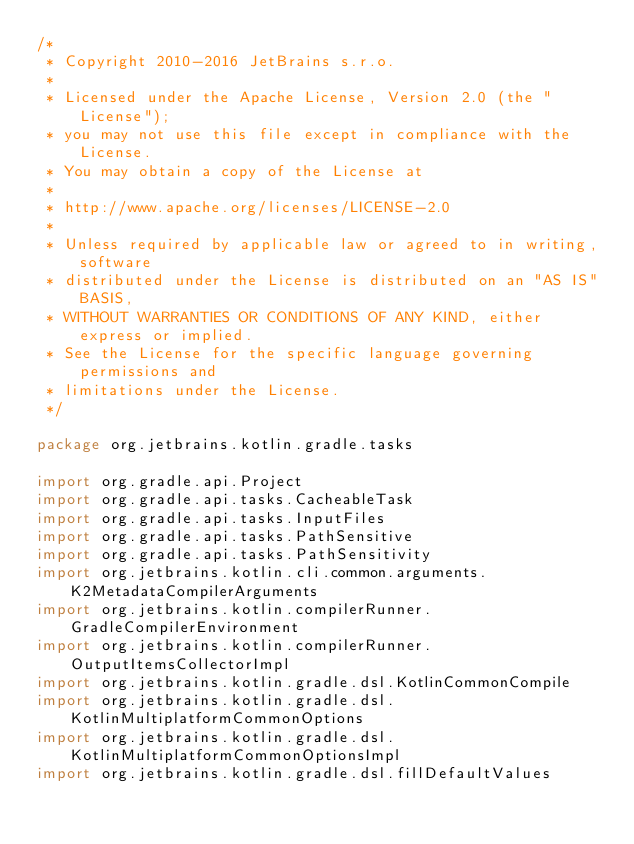<code> <loc_0><loc_0><loc_500><loc_500><_Kotlin_>/*
 * Copyright 2010-2016 JetBrains s.r.o.
 *
 * Licensed under the Apache License, Version 2.0 (the "License");
 * you may not use this file except in compliance with the License.
 * You may obtain a copy of the License at
 *
 * http://www.apache.org/licenses/LICENSE-2.0
 *
 * Unless required by applicable law or agreed to in writing, software
 * distributed under the License is distributed on an "AS IS" BASIS,
 * WITHOUT WARRANTIES OR CONDITIONS OF ANY KIND, either express or implied.
 * See the License for the specific language governing permissions and
 * limitations under the License.
 */

package org.jetbrains.kotlin.gradle.tasks

import org.gradle.api.Project
import org.gradle.api.tasks.CacheableTask
import org.gradle.api.tasks.InputFiles
import org.gradle.api.tasks.PathSensitive
import org.gradle.api.tasks.PathSensitivity
import org.jetbrains.kotlin.cli.common.arguments.K2MetadataCompilerArguments
import org.jetbrains.kotlin.compilerRunner.GradleCompilerEnvironment
import org.jetbrains.kotlin.compilerRunner.OutputItemsCollectorImpl
import org.jetbrains.kotlin.gradle.dsl.KotlinCommonCompile
import org.jetbrains.kotlin.gradle.dsl.KotlinMultiplatformCommonOptions
import org.jetbrains.kotlin.gradle.dsl.KotlinMultiplatformCommonOptionsImpl
import org.jetbrains.kotlin.gradle.dsl.fillDefaultValues</code> 